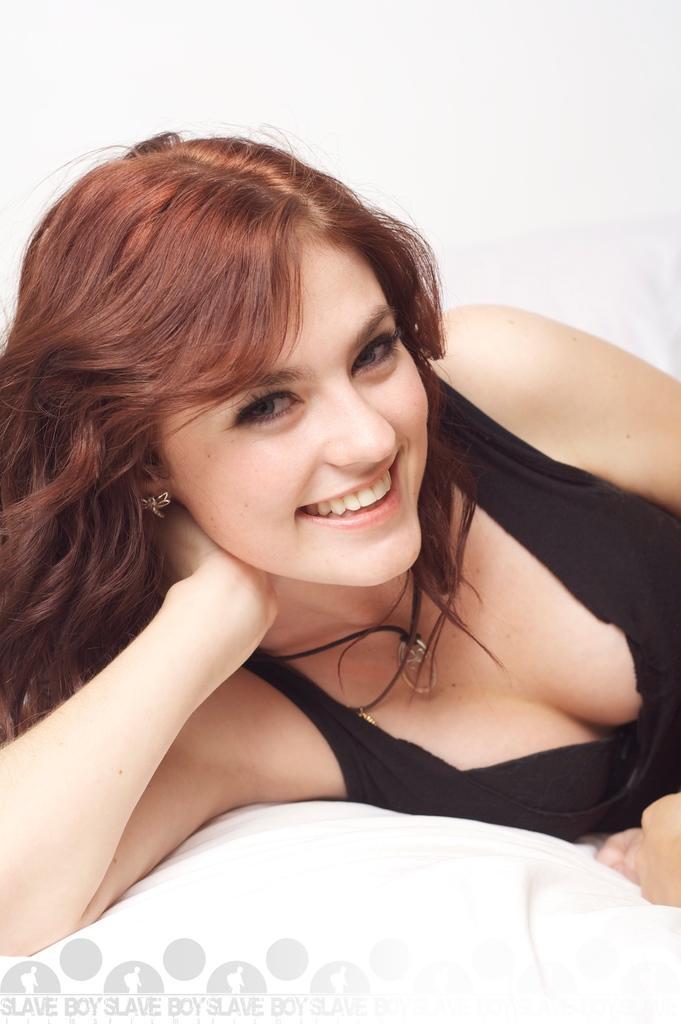Could you give a brief overview of what you see in this image? In this image we can see a lady person wearing black color dress lying on the bed. 